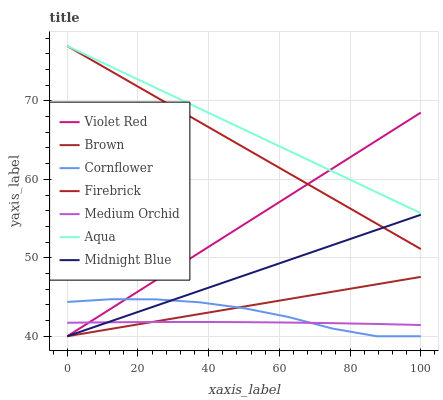Does Violet Red have the minimum area under the curve?
Answer yes or no. No. Does Violet Red have the maximum area under the curve?
Answer yes or no. No. Is Violet Red the smoothest?
Answer yes or no. No. Is Violet Red the roughest?
Answer yes or no. No. Does Firebrick have the lowest value?
Answer yes or no. No. Does Violet Red have the highest value?
Answer yes or no. No. Is Brown less than Aqua?
Answer yes or no. Yes. Is Aqua greater than Midnight Blue?
Answer yes or no. Yes. Does Brown intersect Aqua?
Answer yes or no. No. 